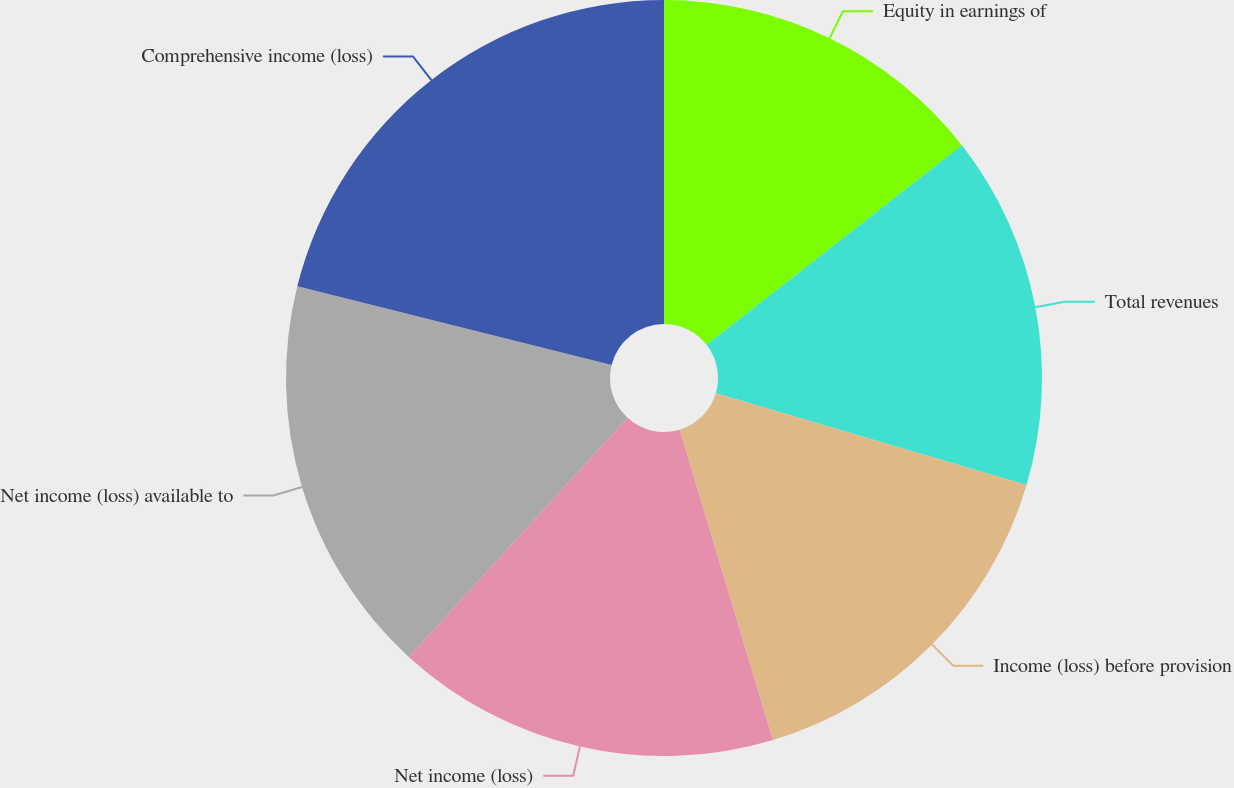<chart> <loc_0><loc_0><loc_500><loc_500><pie_chart><fcel>Equity in earnings of<fcel>Total revenues<fcel>Income (loss) before provision<fcel>Net income (loss)<fcel>Net income (loss) available to<fcel>Comprehensive income (loss)<nl><fcel>14.45%<fcel>15.12%<fcel>15.78%<fcel>16.45%<fcel>17.11%<fcel>21.1%<nl></chart> 